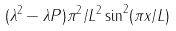Convert formula to latex. <formula><loc_0><loc_0><loc_500><loc_500>( \lambda ^ { 2 } - \lambda P ) \pi ^ { 2 } / L ^ { 2 } \sin ^ { 2 } ( \pi x / L )</formula> 